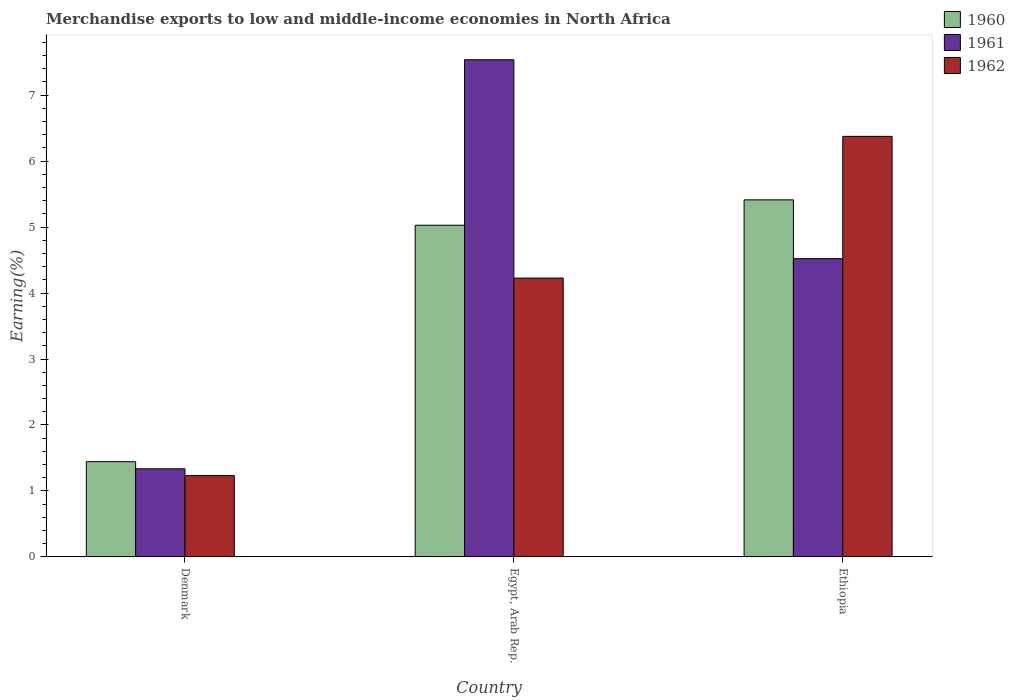How many different coloured bars are there?
Provide a succinct answer. 3. How many groups of bars are there?
Your answer should be compact. 3. Are the number of bars on each tick of the X-axis equal?
Your response must be concise. Yes. What is the label of the 2nd group of bars from the left?
Offer a very short reply. Egypt, Arab Rep. In how many cases, is the number of bars for a given country not equal to the number of legend labels?
Ensure brevity in your answer.  0. What is the percentage of amount earned from merchandise exports in 1960 in Denmark?
Your response must be concise. 1.44. Across all countries, what is the maximum percentage of amount earned from merchandise exports in 1962?
Offer a terse response. 6.38. Across all countries, what is the minimum percentage of amount earned from merchandise exports in 1962?
Your answer should be very brief. 1.23. In which country was the percentage of amount earned from merchandise exports in 1962 maximum?
Provide a short and direct response. Ethiopia. In which country was the percentage of amount earned from merchandise exports in 1962 minimum?
Your response must be concise. Denmark. What is the total percentage of amount earned from merchandise exports in 1960 in the graph?
Keep it short and to the point. 11.88. What is the difference between the percentage of amount earned from merchandise exports in 1961 in Denmark and that in Egypt, Arab Rep.?
Offer a terse response. -6.2. What is the difference between the percentage of amount earned from merchandise exports in 1962 in Egypt, Arab Rep. and the percentage of amount earned from merchandise exports in 1961 in Ethiopia?
Your answer should be compact. -0.29. What is the average percentage of amount earned from merchandise exports in 1962 per country?
Provide a short and direct response. 3.94. What is the difference between the percentage of amount earned from merchandise exports of/in 1960 and percentage of amount earned from merchandise exports of/in 1961 in Egypt, Arab Rep.?
Give a very brief answer. -2.51. What is the ratio of the percentage of amount earned from merchandise exports in 1962 in Egypt, Arab Rep. to that in Ethiopia?
Your answer should be compact. 0.66. Is the percentage of amount earned from merchandise exports in 1962 in Egypt, Arab Rep. less than that in Ethiopia?
Your answer should be compact. Yes. What is the difference between the highest and the second highest percentage of amount earned from merchandise exports in 1962?
Provide a short and direct response. -2.99. What is the difference between the highest and the lowest percentage of amount earned from merchandise exports in 1961?
Ensure brevity in your answer.  6.2. What does the 2nd bar from the left in Denmark represents?
Provide a succinct answer. 1961. What does the 3rd bar from the right in Ethiopia represents?
Provide a short and direct response. 1960. Is it the case that in every country, the sum of the percentage of amount earned from merchandise exports in 1962 and percentage of amount earned from merchandise exports in 1961 is greater than the percentage of amount earned from merchandise exports in 1960?
Ensure brevity in your answer.  Yes. How many bars are there?
Your answer should be compact. 9. Are all the bars in the graph horizontal?
Give a very brief answer. No. How many countries are there in the graph?
Provide a succinct answer. 3. Are the values on the major ticks of Y-axis written in scientific E-notation?
Your response must be concise. No. Does the graph contain any zero values?
Your answer should be very brief. No. Where does the legend appear in the graph?
Keep it short and to the point. Top right. What is the title of the graph?
Make the answer very short. Merchandise exports to low and middle-income economies in North Africa. Does "1988" appear as one of the legend labels in the graph?
Offer a terse response. No. What is the label or title of the Y-axis?
Ensure brevity in your answer.  Earning(%). What is the Earning(%) in 1960 in Denmark?
Your response must be concise. 1.44. What is the Earning(%) in 1961 in Denmark?
Your response must be concise. 1.34. What is the Earning(%) in 1962 in Denmark?
Provide a short and direct response. 1.23. What is the Earning(%) in 1960 in Egypt, Arab Rep.?
Ensure brevity in your answer.  5.03. What is the Earning(%) of 1961 in Egypt, Arab Rep.?
Your response must be concise. 7.54. What is the Earning(%) in 1962 in Egypt, Arab Rep.?
Provide a succinct answer. 4.23. What is the Earning(%) in 1960 in Ethiopia?
Ensure brevity in your answer.  5.41. What is the Earning(%) of 1961 in Ethiopia?
Your answer should be compact. 4.52. What is the Earning(%) in 1962 in Ethiopia?
Give a very brief answer. 6.38. Across all countries, what is the maximum Earning(%) of 1960?
Your answer should be very brief. 5.41. Across all countries, what is the maximum Earning(%) of 1961?
Ensure brevity in your answer.  7.54. Across all countries, what is the maximum Earning(%) of 1962?
Offer a terse response. 6.38. Across all countries, what is the minimum Earning(%) of 1960?
Give a very brief answer. 1.44. Across all countries, what is the minimum Earning(%) of 1961?
Provide a short and direct response. 1.34. Across all countries, what is the minimum Earning(%) of 1962?
Give a very brief answer. 1.23. What is the total Earning(%) of 1960 in the graph?
Offer a very short reply. 11.88. What is the total Earning(%) in 1961 in the graph?
Offer a terse response. 13.39. What is the total Earning(%) in 1962 in the graph?
Make the answer very short. 11.83. What is the difference between the Earning(%) in 1960 in Denmark and that in Egypt, Arab Rep.?
Provide a succinct answer. -3.58. What is the difference between the Earning(%) of 1961 in Denmark and that in Egypt, Arab Rep.?
Your response must be concise. -6.2. What is the difference between the Earning(%) in 1962 in Denmark and that in Egypt, Arab Rep.?
Offer a terse response. -2.99. What is the difference between the Earning(%) of 1960 in Denmark and that in Ethiopia?
Offer a terse response. -3.97. What is the difference between the Earning(%) of 1961 in Denmark and that in Ethiopia?
Provide a succinct answer. -3.19. What is the difference between the Earning(%) in 1962 in Denmark and that in Ethiopia?
Ensure brevity in your answer.  -5.14. What is the difference between the Earning(%) of 1960 in Egypt, Arab Rep. and that in Ethiopia?
Give a very brief answer. -0.38. What is the difference between the Earning(%) in 1961 in Egypt, Arab Rep. and that in Ethiopia?
Make the answer very short. 3.02. What is the difference between the Earning(%) of 1962 in Egypt, Arab Rep. and that in Ethiopia?
Keep it short and to the point. -2.15. What is the difference between the Earning(%) in 1960 in Denmark and the Earning(%) in 1961 in Egypt, Arab Rep.?
Your response must be concise. -6.09. What is the difference between the Earning(%) in 1960 in Denmark and the Earning(%) in 1962 in Egypt, Arab Rep.?
Keep it short and to the point. -2.78. What is the difference between the Earning(%) of 1961 in Denmark and the Earning(%) of 1962 in Egypt, Arab Rep.?
Your answer should be very brief. -2.89. What is the difference between the Earning(%) in 1960 in Denmark and the Earning(%) in 1961 in Ethiopia?
Give a very brief answer. -3.08. What is the difference between the Earning(%) of 1960 in Denmark and the Earning(%) of 1962 in Ethiopia?
Your answer should be very brief. -4.93. What is the difference between the Earning(%) in 1961 in Denmark and the Earning(%) in 1962 in Ethiopia?
Ensure brevity in your answer.  -5.04. What is the difference between the Earning(%) in 1960 in Egypt, Arab Rep. and the Earning(%) in 1961 in Ethiopia?
Provide a succinct answer. 0.51. What is the difference between the Earning(%) in 1960 in Egypt, Arab Rep. and the Earning(%) in 1962 in Ethiopia?
Your response must be concise. -1.35. What is the difference between the Earning(%) of 1961 in Egypt, Arab Rep. and the Earning(%) of 1962 in Ethiopia?
Provide a succinct answer. 1.16. What is the average Earning(%) of 1960 per country?
Provide a succinct answer. 3.96. What is the average Earning(%) in 1961 per country?
Give a very brief answer. 4.46. What is the average Earning(%) of 1962 per country?
Provide a succinct answer. 3.94. What is the difference between the Earning(%) in 1960 and Earning(%) in 1961 in Denmark?
Offer a very short reply. 0.11. What is the difference between the Earning(%) of 1960 and Earning(%) of 1962 in Denmark?
Offer a terse response. 0.21. What is the difference between the Earning(%) of 1961 and Earning(%) of 1962 in Denmark?
Provide a succinct answer. 0.1. What is the difference between the Earning(%) in 1960 and Earning(%) in 1961 in Egypt, Arab Rep.?
Provide a succinct answer. -2.51. What is the difference between the Earning(%) of 1960 and Earning(%) of 1962 in Egypt, Arab Rep.?
Provide a short and direct response. 0.8. What is the difference between the Earning(%) in 1961 and Earning(%) in 1962 in Egypt, Arab Rep.?
Give a very brief answer. 3.31. What is the difference between the Earning(%) of 1960 and Earning(%) of 1961 in Ethiopia?
Make the answer very short. 0.89. What is the difference between the Earning(%) of 1960 and Earning(%) of 1962 in Ethiopia?
Offer a terse response. -0.96. What is the difference between the Earning(%) in 1961 and Earning(%) in 1962 in Ethiopia?
Give a very brief answer. -1.85. What is the ratio of the Earning(%) of 1960 in Denmark to that in Egypt, Arab Rep.?
Your answer should be very brief. 0.29. What is the ratio of the Earning(%) of 1961 in Denmark to that in Egypt, Arab Rep.?
Provide a short and direct response. 0.18. What is the ratio of the Earning(%) in 1962 in Denmark to that in Egypt, Arab Rep.?
Make the answer very short. 0.29. What is the ratio of the Earning(%) of 1960 in Denmark to that in Ethiopia?
Give a very brief answer. 0.27. What is the ratio of the Earning(%) of 1961 in Denmark to that in Ethiopia?
Keep it short and to the point. 0.3. What is the ratio of the Earning(%) of 1962 in Denmark to that in Ethiopia?
Provide a succinct answer. 0.19. What is the ratio of the Earning(%) in 1960 in Egypt, Arab Rep. to that in Ethiopia?
Your answer should be very brief. 0.93. What is the ratio of the Earning(%) in 1961 in Egypt, Arab Rep. to that in Ethiopia?
Your response must be concise. 1.67. What is the ratio of the Earning(%) in 1962 in Egypt, Arab Rep. to that in Ethiopia?
Your answer should be compact. 0.66. What is the difference between the highest and the second highest Earning(%) of 1960?
Keep it short and to the point. 0.38. What is the difference between the highest and the second highest Earning(%) in 1961?
Offer a very short reply. 3.02. What is the difference between the highest and the second highest Earning(%) of 1962?
Ensure brevity in your answer.  2.15. What is the difference between the highest and the lowest Earning(%) of 1960?
Give a very brief answer. 3.97. What is the difference between the highest and the lowest Earning(%) of 1961?
Provide a short and direct response. 6.2. What is the difference between the highest and the lowest Earning(%) in 1962?
Offer a terse response. 5.14. 